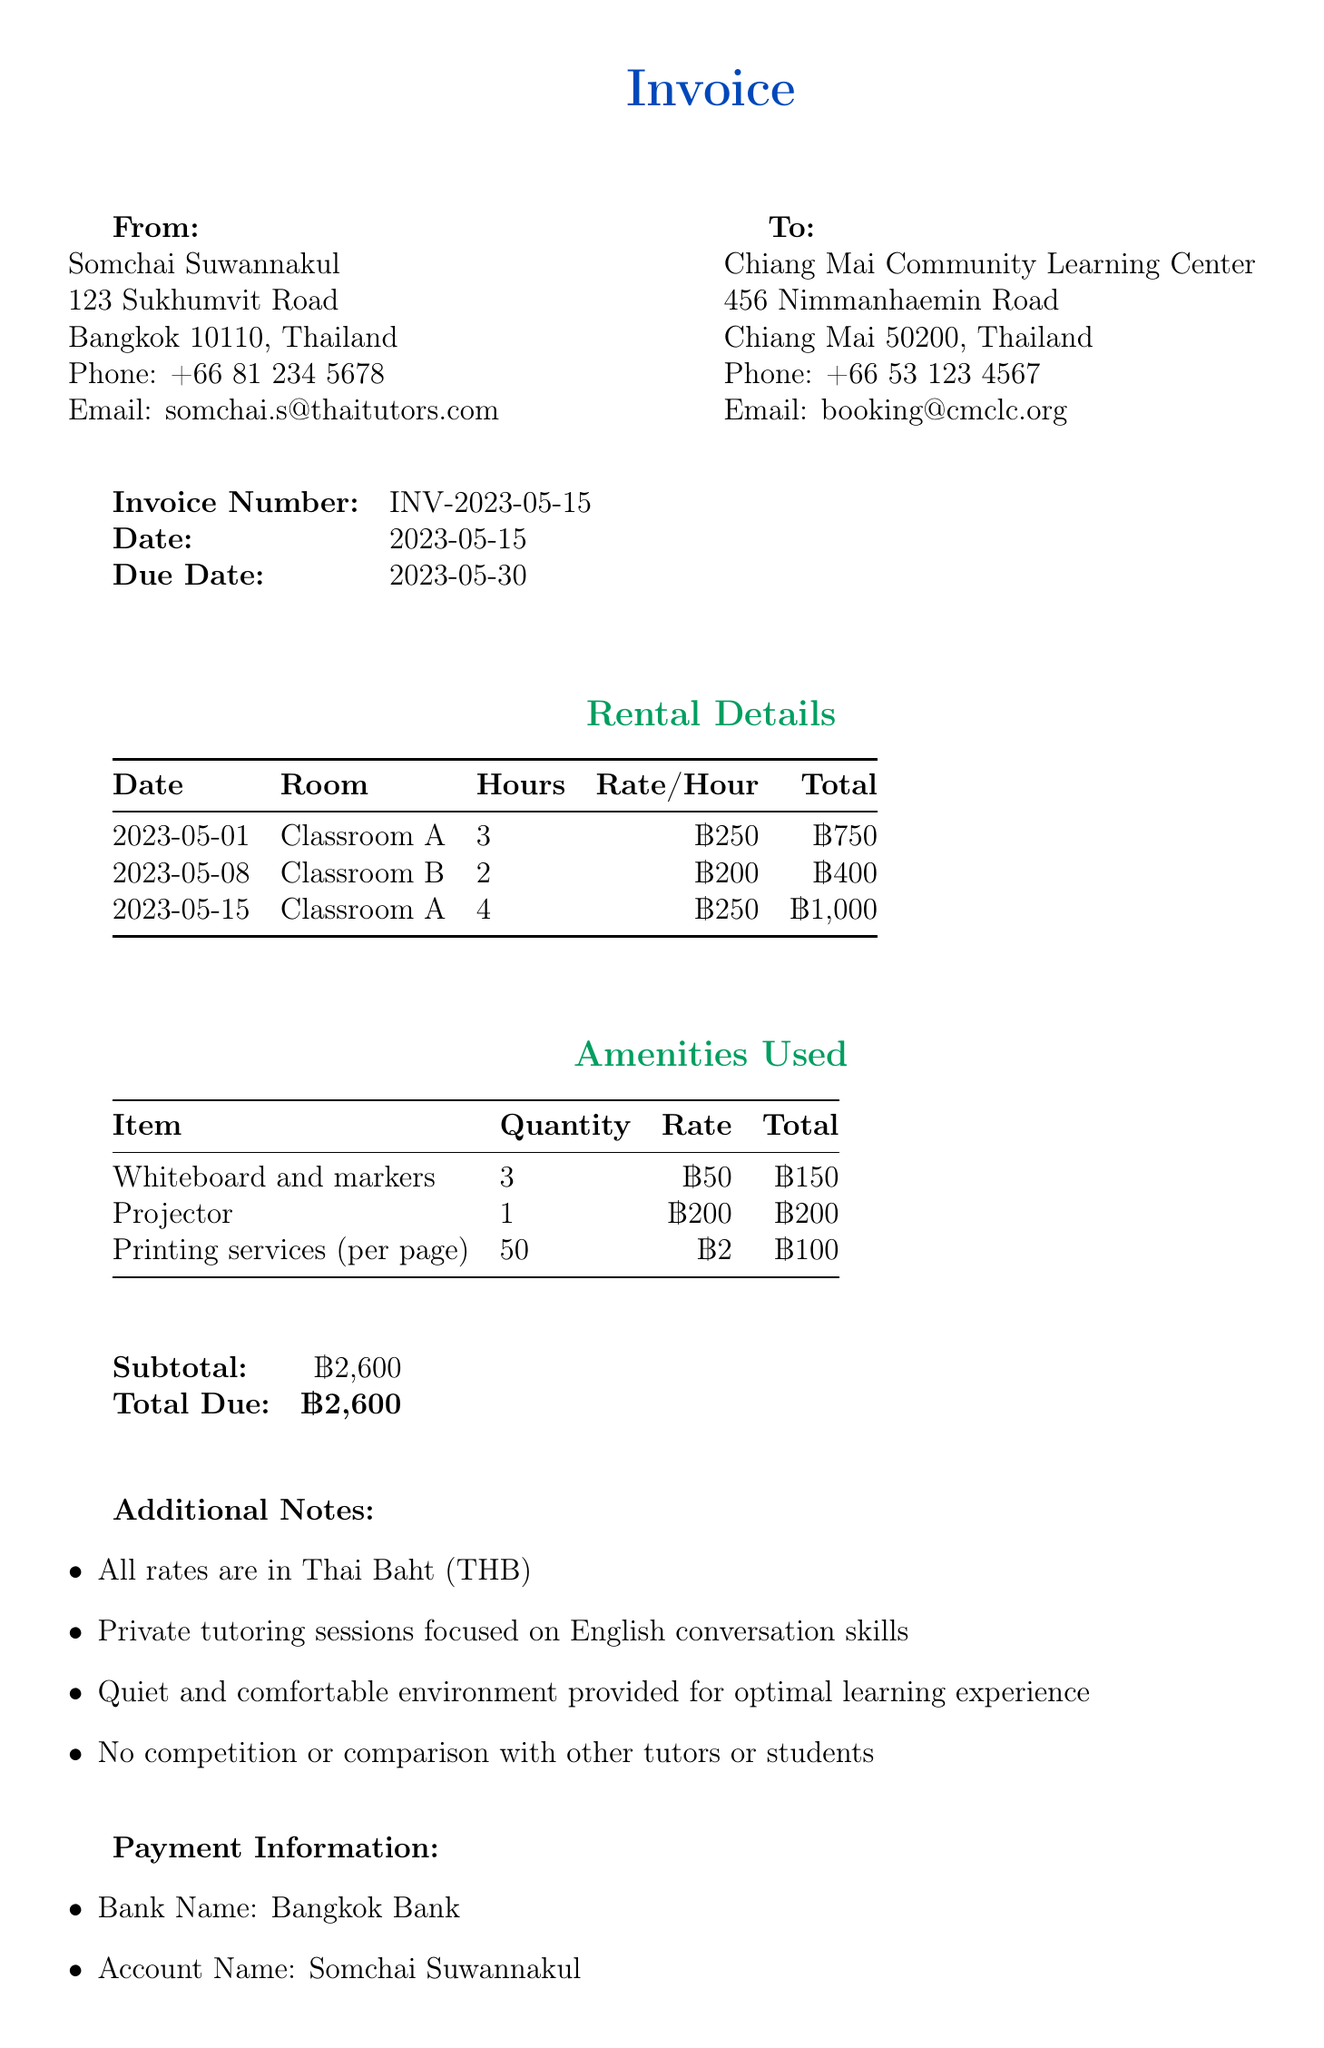what is the invoice number? The invoice number is a unique identifier for this specific transaction found in the invoice details.
Answer: INV-2023-05-15 what is the total due amount? The total due amount is the sum of all rental and amenity costs outlined in the invoice.
Answer: ฿2,600 who is the teacher? The teacher's name is provided in the document's "From" section and identifies the individual responsible for the tutoring sessions.
Answer: Somchai Suwannakul how many hours was Classroom A rented on 2023-05-15? The invoice lists the rental details by date, showing specific hours for each classroom.
Answer: 4 what amenities were used? The amenities used are detailed in their own section, including all items rented or used during the sessions.
Answer: Whiteboard and markers, Projector, Printing services what is the room rate for Classroom B? The rate per hour for Classroom B is specified in the rental details, indicating the pricing for that room.
Answer: ฿200 what is the due date for the invoice? The due date indicates when payment for the services rendered is expected and is clearly mentioned in the document.
Answer: 2023-05-30 how many pages of printing services were used? The quantity of printing services used is listed in the amenities section, providing clear details on the volume rented.
Answer: 50 what is the bank name for payment? The bank name is given in the payment information section, informing clients where to send their payments.
Answer: Bangkok Bank 